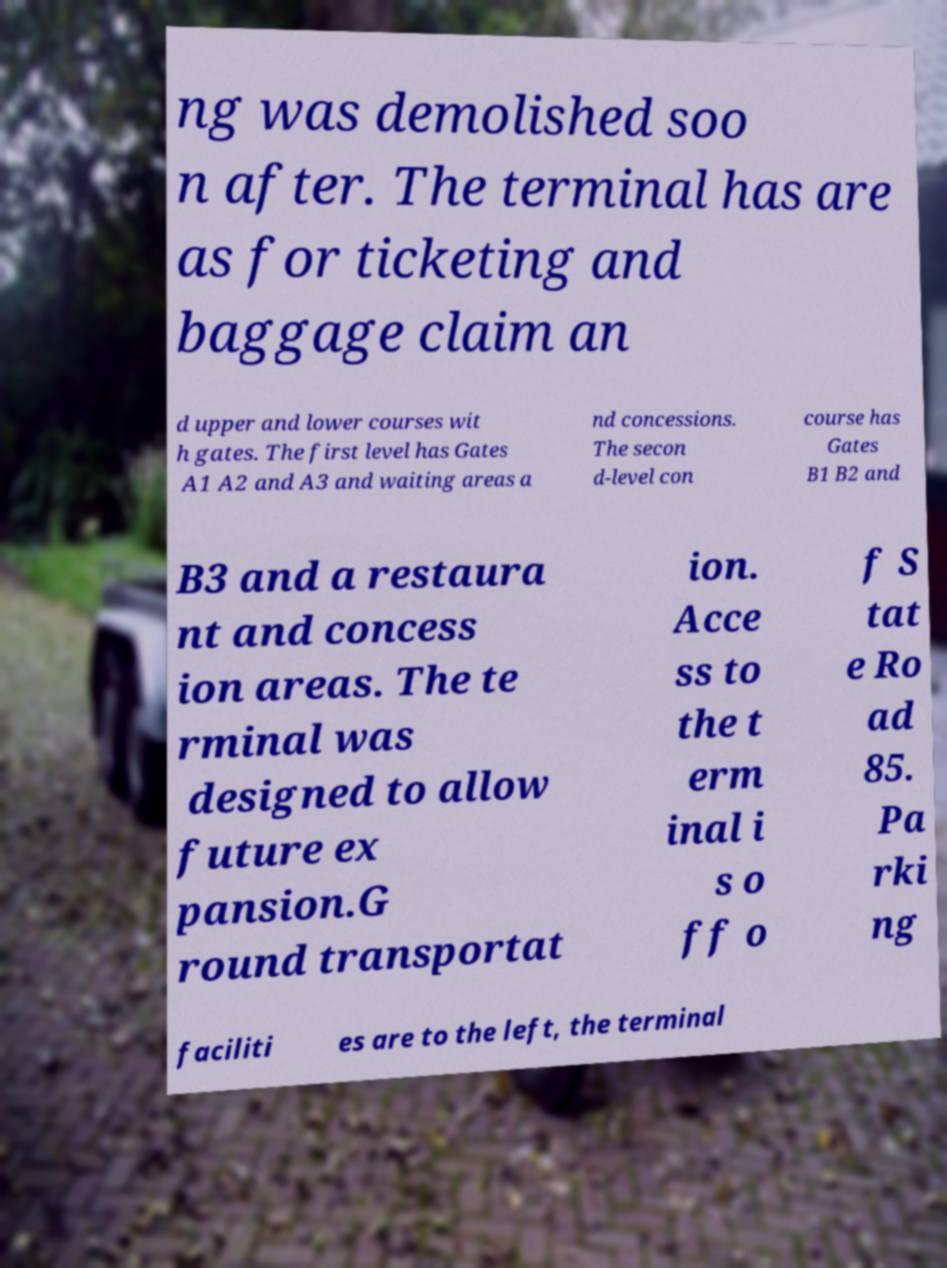Please identify and transcribe the text found in this image. ng was demolished soo n after. The terminal has are as for ticketing and baggage claim an d upper and lower courses wit h gates. The first level has Gates A1 A2 and A3 and waiting areas a nd concessions. The secon d-level con course has Gates B1 B2 and B3 and a restaura nt and concess ion areas. The te rminal was designed to allow future ex pansion.G round transportat ion. Acce ss to the t erm inal i s o ff o f S tat e Ro ad 85. Pa rki ng faciliti es are to the left, the terminal 